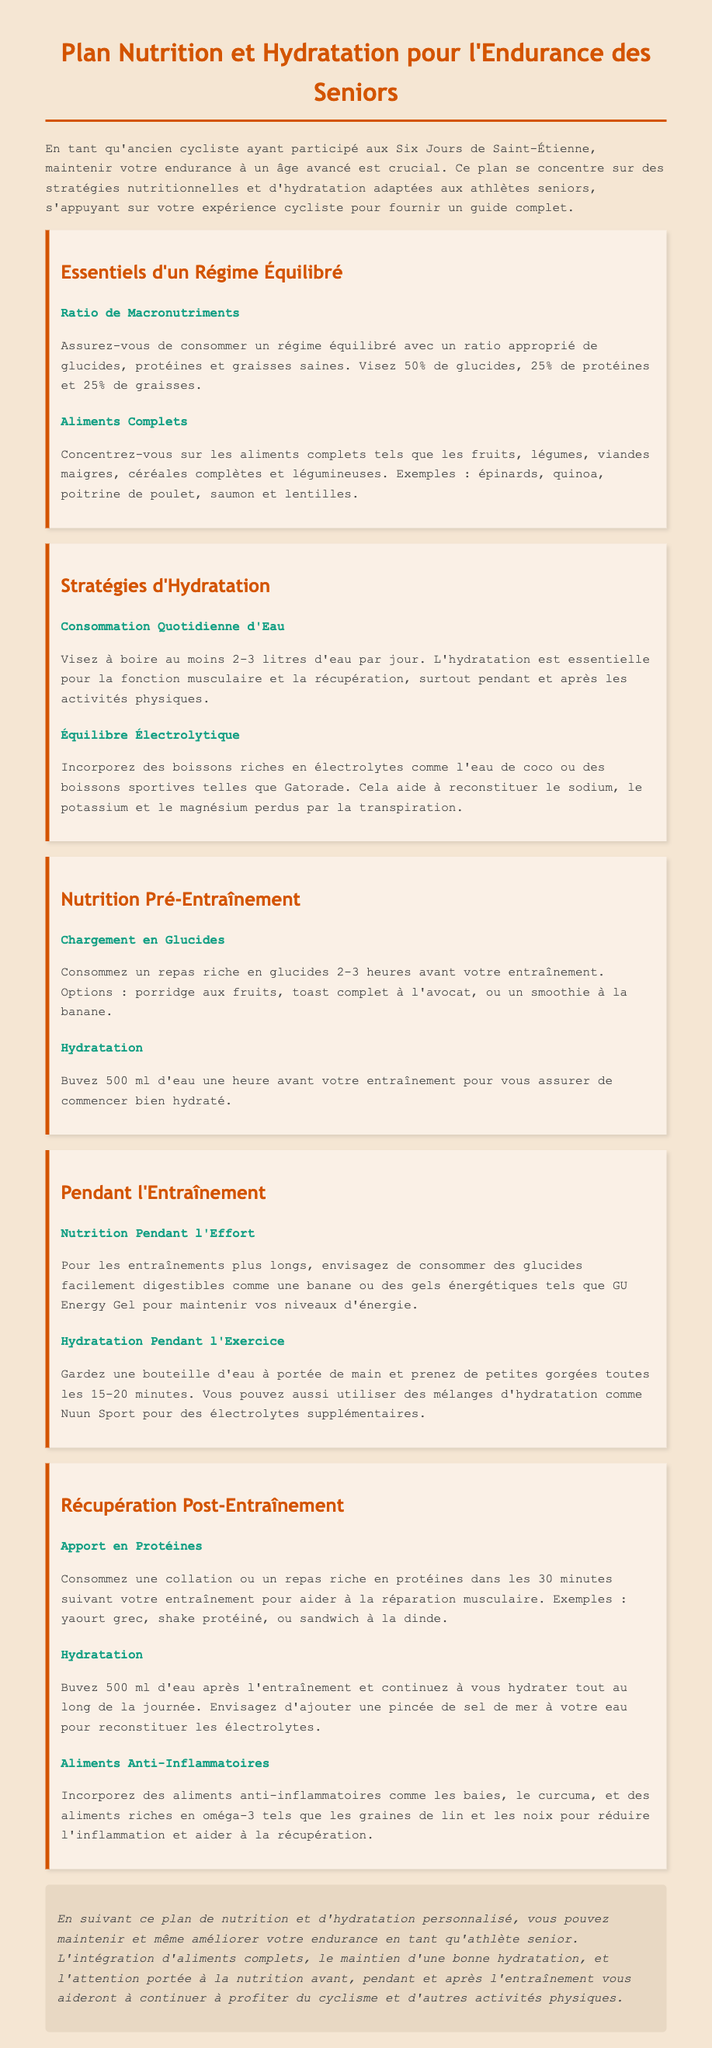Quel est le ratio recommandé de macronutriments ? Le document indique de viser 50% de glucides, 25% de protéines et 25% de graisses.
Answer: 50% glucides, 25% protéines, 25% graisses Quelle quantité d'eau est-elle recommandée par jour ? Le document suggère de viser à boire au moins 2-3 litres d'eau par jour.
Answer: 2-3 litres Quel type de repas doit-on consommer avant l'entraînement ? Le document recommande un repas riche en glucides 2-3 heures avant l'entraînement.
Answer: Repas riche en glucides Quelle est une option de collation pour la récupération post-entraînement ? Le document mentionne des exemples comme le yaourt grec, un shake protéiné, ou un sandwich à la dinde.
Answer: Yaourt grec, shake protéiné, sandwich à la dinde Quel aliment est recommandé pour reconstituer les électrolytes après l'entraînement ? Le document conseille d'ajouter une pincée de sel de mer à votre eau pour reconstituer les électrolytes.
Answer: Pincée de sel de mer Quels aliments sont mentionnés comme anti-inflammatoires ? Le document inclut des aliments comme les baies, le curcuma, et des aliments riches en oméga-3.
Answer: Baies, curcuma, oméga-3 Quelle boisson est suggérée pour l'hydratation pendant l'exercice ? Le document recommande des mélanges d'hydratation comme Nuun Sport pour des électrolytes supplémentaires.
Answer: Nuun Sport Combien de temps avant l'entraînement faut-il boire de l'eau ? Il est conseillé de boire 500 ml d'eau une heure avant votre entraînement.
Answer: 500 ml une heure avant 